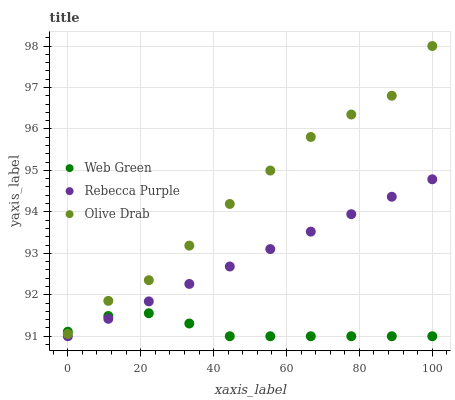Does Web Green have the minimum area under the curve?
Answer yes or no. Yes. Does Olive Drab have the maximum area under the curve?
Answer yes or no. Yes. Does Rebecca Purple have the minimum area under the curve?
Answer yes or no. No. Does Rebecca Purple have the maximum area under the curve?
Answer yes or no. No. Is Rebecca Purple the smoothest?
Answer yes or no. Yes. Is Olive Drab the roughest?
Answer yes or no. Yes. Is Web Green the smoothest?
Answer yes or no. No. Is Web Green the roughest?
Answer yes or no. No. Does Rebecca Purple have the lowest value?
Answer yes or no. Yes. Does Olive Drab have the highest value?
Answer yes or no. Yes. Does Rebecca Purple have the highest value?
Answer yes or no. No. Is Rebecca Purple less than Olive Drab?
Answer yes or no. Yes. Is Olive Drab greater than Rebecca Purple?
Answer yes or no. Yes. Does Olive Drab intersect Web Green?
Answer yes or no. Yes. Is Olive Drab less than Web Green?
Answer yes or no. No. Is Olive Drab greater than Web Green?
Answer yes or no. No. Does Rebecca Purple intersect Olive Drab?
Answer yes or no. No. 